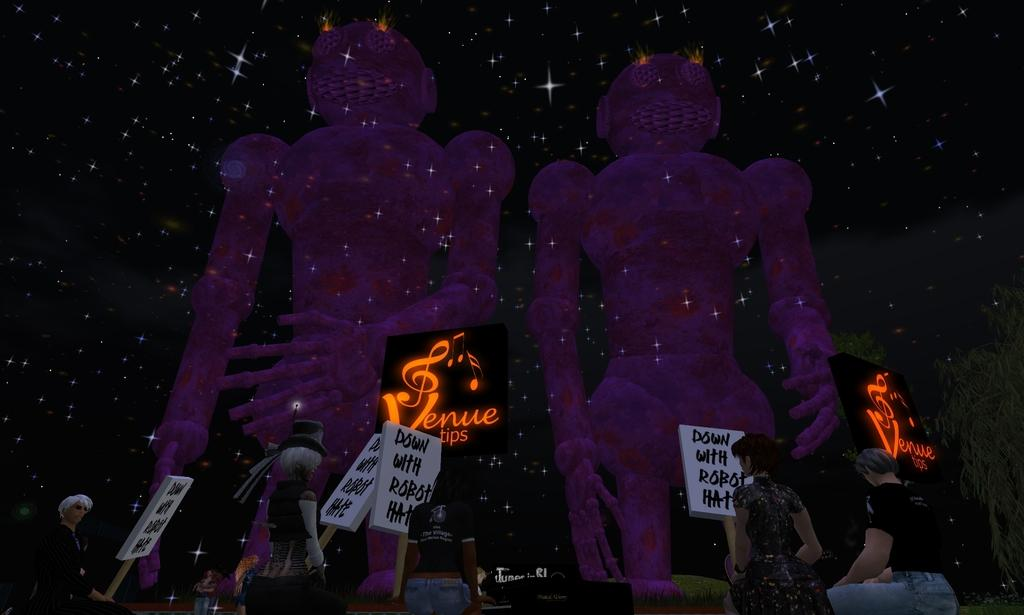Who or what can be seen in the image? There are people in the image. What objects are present in the image besides the people? There are boards, stars, and trees in the image. What is written on the boards? There is writing on the boards. What type of plough is being used to cultivate the land in the image? There is no plough present in the image; it features people, boards, stars, and trees. What historical event is depicted in the image? The image does not depict any specific historical event; it simply shows people, boards, stars, and trees. 